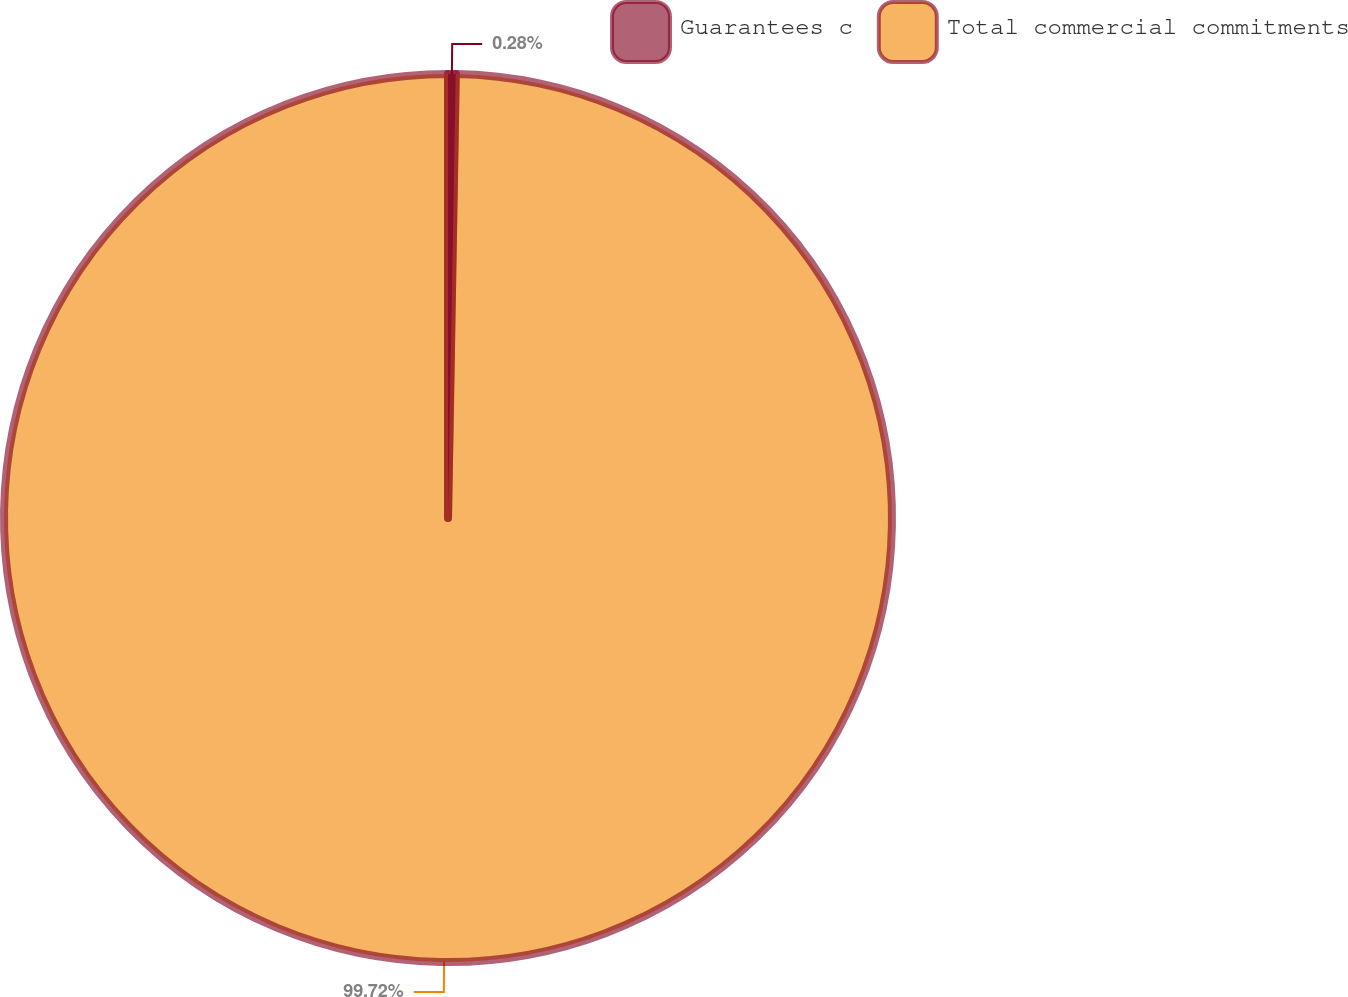Convert chart. <chart><loc_0><loc_0><loc_500><loc_500><pie_chart><fcel>Guarantees c<fcel>Total commercial commitments<nl><fcel>0.28%<fcel>99.72%<nl></chart> 